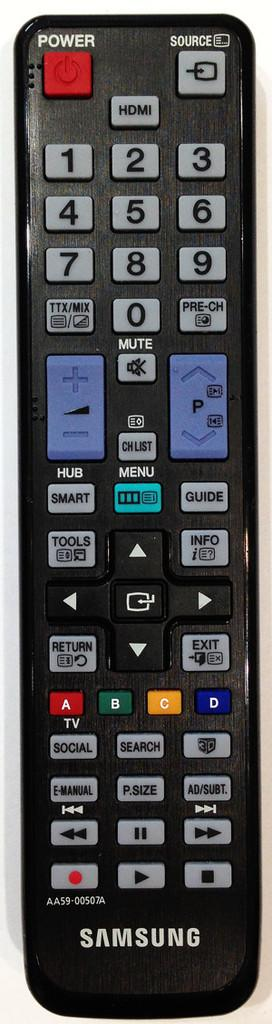<image>
Write a terse but informative summary of the picture. a Samsung remote control with the power and source buttons on the top where they should be, and other buttons like MUTE, MENU, TOOLS, EXIT, and others. 